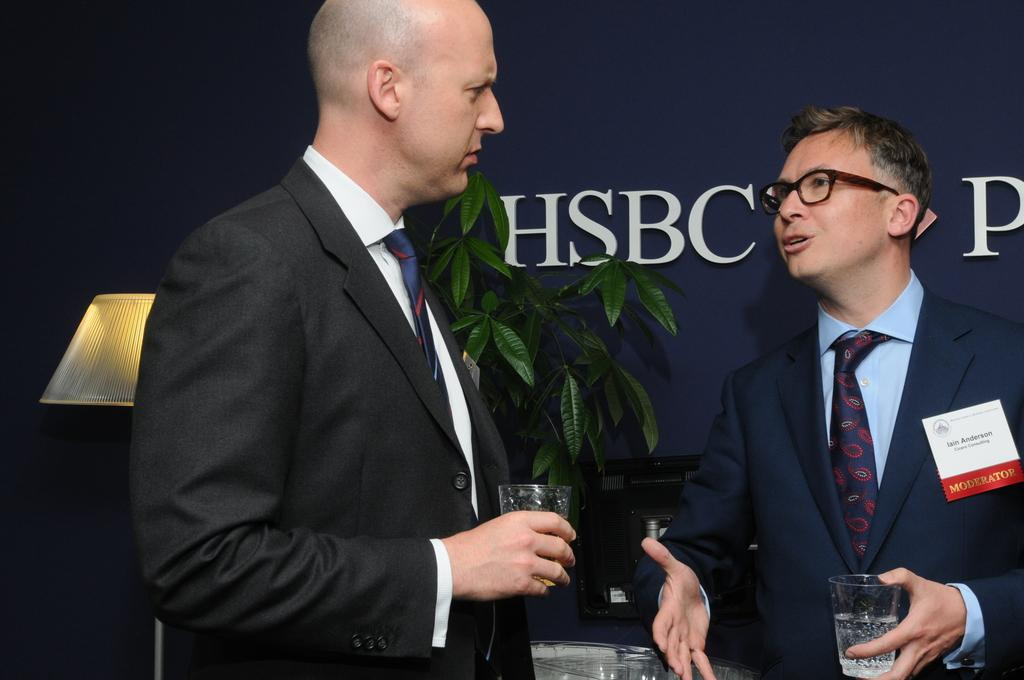What are the men in the image holding? The men are holding glass tumblers in their hands. What can be seen in the background of the image? There is an advertisement, a desktop, a houseplant, and a table lamp in the background of the image. Can you describe the setting where the men are standing? The men are standing in a room with a table, a desktop, and a houseplant in the background. Are there any fairies visible in the image? No, there are no fairies present in the image. Can you describe the type of mitten the men are wearing in the image? The men are not wearing mittens in the image; they are holding glass tumblers in their hands. 